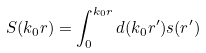<formula> <loc_0><loc_0><loc_500><loc_500>S ( k _ { 0 } r ) = \int _ { 0 } ^ { k _ { 0 } r } d ( k _ { 0 } r ^ { \prime } ) s ( r ^ { \prime } )</formula> 